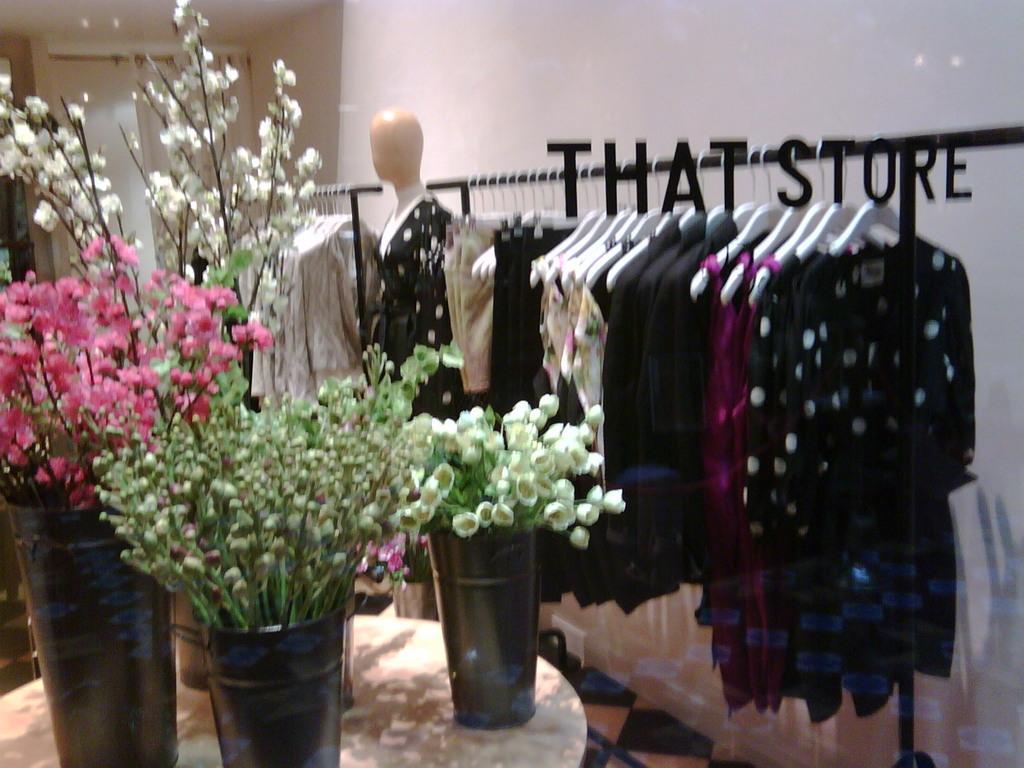Please provide a concise description of this image. In this picture we see a clothing store with many dresses hanged for display. Here we see a white table on which 4 flower pots are present with different flowers. 